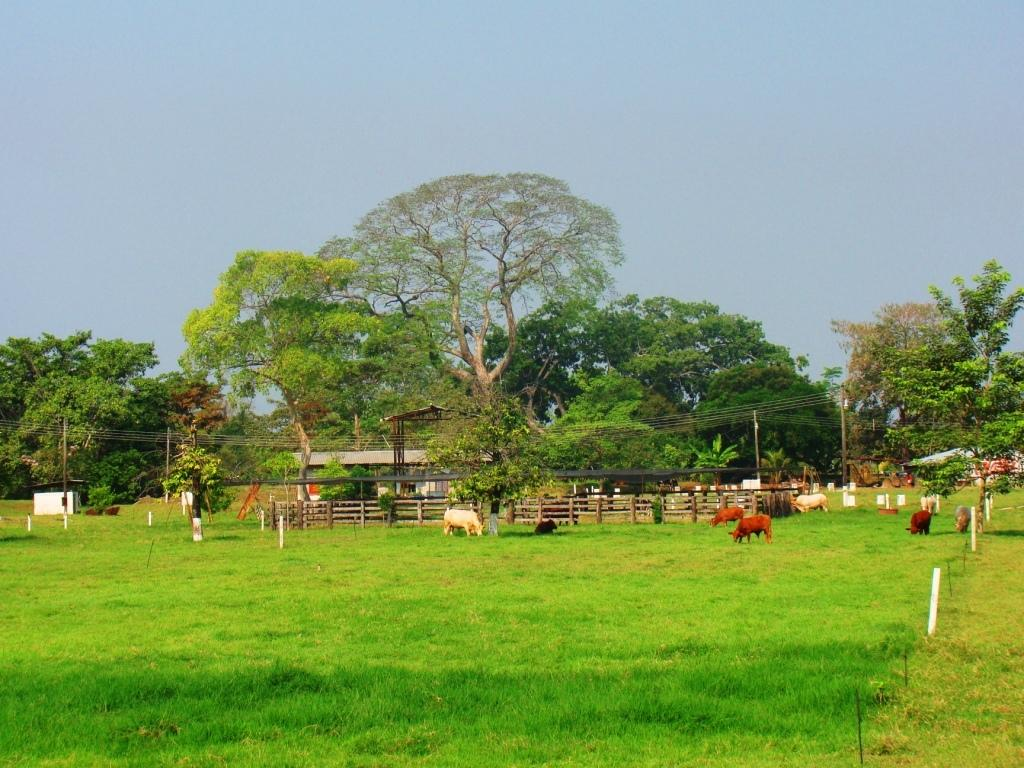What type of vegetation is present in the image? There are trees and grass in the image. What animals can be seen in the image? There are horses in the image. What type of barrier is present in the image? There is fencing in the image. What type of structure is visible in the image? There is a house in the image. What other objects can be seen in the image? There are poles in the image. What part of the natural environment is visible in the image? The sky is visible in the image. What type of yarn is being used to create the fence in the image? There is no yarn present in the image; the fence is made of a different material. What type of engine can be seen powering the horses in the image? There are no engines present in the image; the horses are not mechanical. 